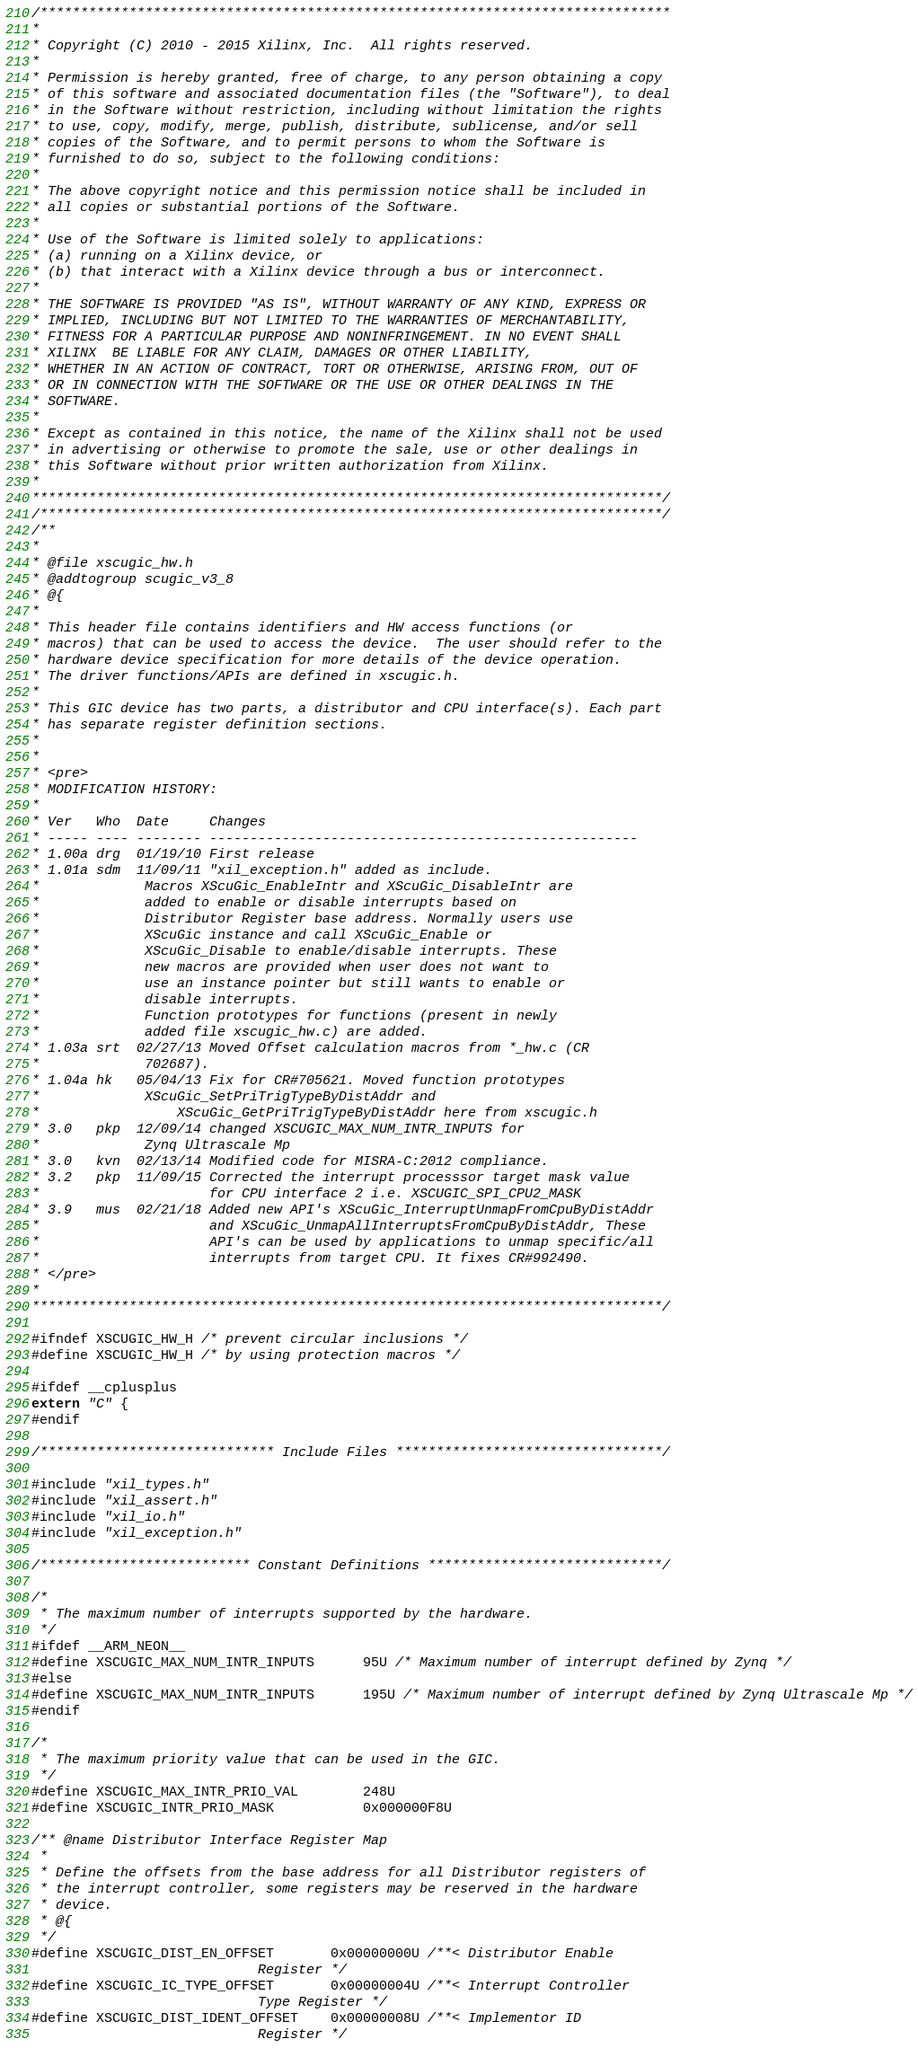<code> <loc_0><loc_0><loc_500><loc_500><_C_>/******************************************************************************
*
* Copyright (C) 2010 - 2015 Xilinx, Inc.  All rights reserved.
*
* Permission is hereby granted, free of charge, to any person obtaining a copy
* of this software and associated documentation files (the "Software"), to deal
* in the Software without restriction, including without limitation the rights
* to use, copy, modify, merge, publish, distribute, sublicense, and/or sell
* copies of the Software, and to permit persons to whom the Software is
* furnished to do so, subject to the following conditions:
*
* The above copyright notice and this permission notice shall be included in
* all copies or substantial portions of the Software.
*
* Use of the Software is limited solely to applications:
* (a) running on a Xilinx device, or
* (b) that interact with a Xilinx device through a bus or interconnect.
*
* THE SOFTWARE IS PROVIDED "AS IS", WITHOUT WARRANTY OF ANY KIND, EXPRESS OR
* IMPLIED, INCLUDING BUT NOT LIMITED TO THE WARRANTIES OF MERCHANTABILITY,
* FITNESS FOR A PARTICULAR PURPOSE AND NONINFRINGEMENT. IN NO EVENT SHALL
* XILINX  BE LIABLE FOR ANY CLAIM, DAMAGES OR OTHER LIABILITY,
* WHETHER IN AN ACTION OF CONTRACT, TORT OR OTHERWISE, ARISING FROM, OUT OF
* OR IN CONNECTION WITH THE SOFTWARE OR THE USE OR OTHER DEALINGS IN THE
* SOFTWARE.
*
* Except as contained in this notice, the name of the Xilinx shall not be used
* in advertising or otherwise to promote the sale, use or other dealings in
* this Software without prior written authorization from Xilinx.
*
******************************************************************************/
/*****************************************************************************/
/**
*
* @file xscugic_hw.h
* @addtogroup scugic_v3_8
* @{
*
* This header file contains identifiers and HW access functions (or
* macros) that can be used to access the device.  The user should refer to the
* hardware device specification for more details of the device operation.
* The driver functions/APIs are defined in xscugic.h.
*
* This GIC device has two parts, a distributor and CPU interface(s). Each part
* has separate register definition sections.
*
*
* <pre>
* MODIFICATION HISTORY:
*
* Ver   Who  Date     Changes
* ----- ---- -------- -----------------------------------------------------
* 1.00a drg  01/19/10 First release
* 1.01a sdm  11/09/11 "xil_exception.h" added as include.
*		      Macros XScuGic_EnableIntr and XScuGic_DisableIntr are
*		      added to enable or disable interrupts based on
*		      Distributor Register base address. Normally users use
*		      XScuGic instance and call XScuGic_Enable or
*		      XScuGic_Disable to enable/disable interrupts. These
*		      new macros are provided when user does not want to
*		      use an instance pointer but still wants to enable or
*		      disable interrupts.
*		      Function prototypes for functions (present in newly
*		      added file xscugic_hw.c) are added.
* 1.03a srt  02/27/13 Moved Offset calculation macros from *_hw.c (CR
*		      702687).
* 1.04a hk   05/04/13 Fix for CR#705621. Moved function prototypes
*		      XScuGic_SetPriTrigTypeByDistAddr and
*         	      XScuGic_GetPriTrigTypeByDistAddr here from xscugic.h
* 3.0	pkp  12/09/14 changed XSCUGIC_MAX_NUM_INTR_INPUTS for
*		      Zynq Ultrascale Mp
* 3.0   kvn  02/13/14 Modified code for MISRA-C:2012 compliance.
* 3.2	pkp  11/09/15 Corrected the interrupt processsor target mask value
*					  for CPU interface 2 i.e. XSCUGIC_SPI_CPU2_MASK
* 3.9   mus  02/21/18 Added new API's XScuGic_InterruptUnmapFromCpuByDistAddr
*					  and XScuGic_UnmapAllInterruptsFromCpuByDistAddr, These
*					  API's can be used by applications to unmap specific/all
*					  interrupts from target CPU. It fixes CR#992490.
* </pre>
*
******************************************************************************/

#ifndef XSCUGIC_HW_H /* prevent circular inclusions */
#define XSCUGIC_HW_H /* by using protection macros */

#ifdef __cplusplus
extern "C" {
#endif

/***************************** Include Files *********************************/

#include "xil_types.h"
#include "xil_assert.h"
#include "xil_io.h"
#include "xil_exception.h"

/************************** Constant Definitions *****************************/

/*
 * The maximum number of interrupts supported by the hardware.
 */
#ifdef __ARM_NEON__
#define XSCUGIC_MAX_NUM_INTR_INPUTS    	95U /* Maximum number of interrupt defined by Zynq */
#else
#define XSCUGIC_MAX_NUM_INTR_INPUTS    	195U /* Maximum number of interrupt defined by Zynq Ultrascale Mp */
#endif

/*
 * The maximum priority value that can be used in the GIC.
 */
#define XSCUGIC_MAX_INTR_PRIO_VAL    	248U
#define XSCUGIC_INTR_PRIO_MASK			0x000000F8U

/** @name Distributor Interface Register Map
 *
 * Define the offsets from the base address for all Distributor registers of
 * the interrupt controller, some registers may be reserved in the hardware
 * device.
 * @{
 */
#define XSCUGIC_DIST_EN_OFFSET		0x00000000U /**< Distributor Enable
							Register */
#define XSCUGIC_IC_TYPE_OFFSET		0x00000004U /**< Interrupt Controller
							Type Register */
#define XSCUGIC_DIST_IDENT_OFFSET	0x00000008U /**< Implementor ID
							Register */</code> 